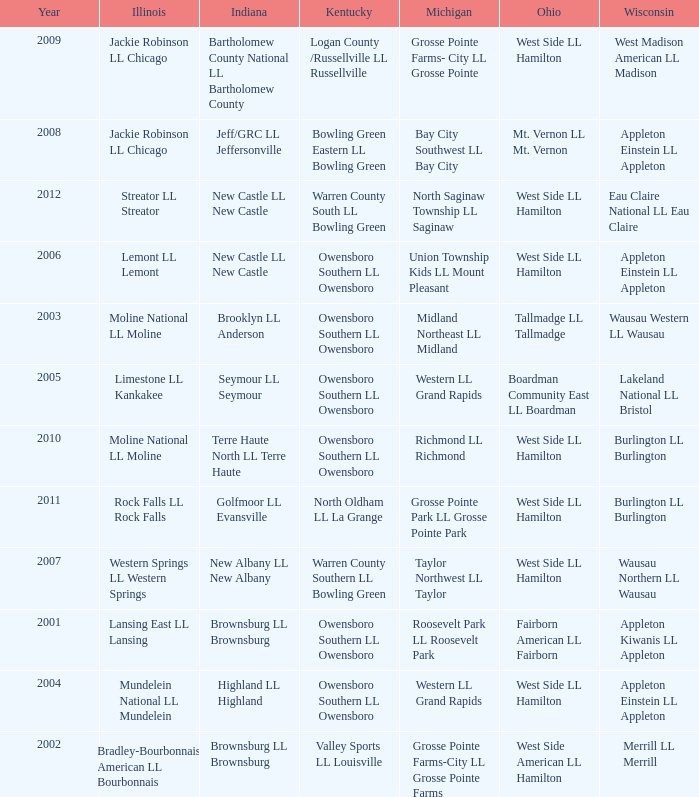What was the little league team from Kentucky when the little league team from Michigan was Grosse Pointe Farms-City LL Grosse Pointe Farms?  Valley Sports LL Louisville. 